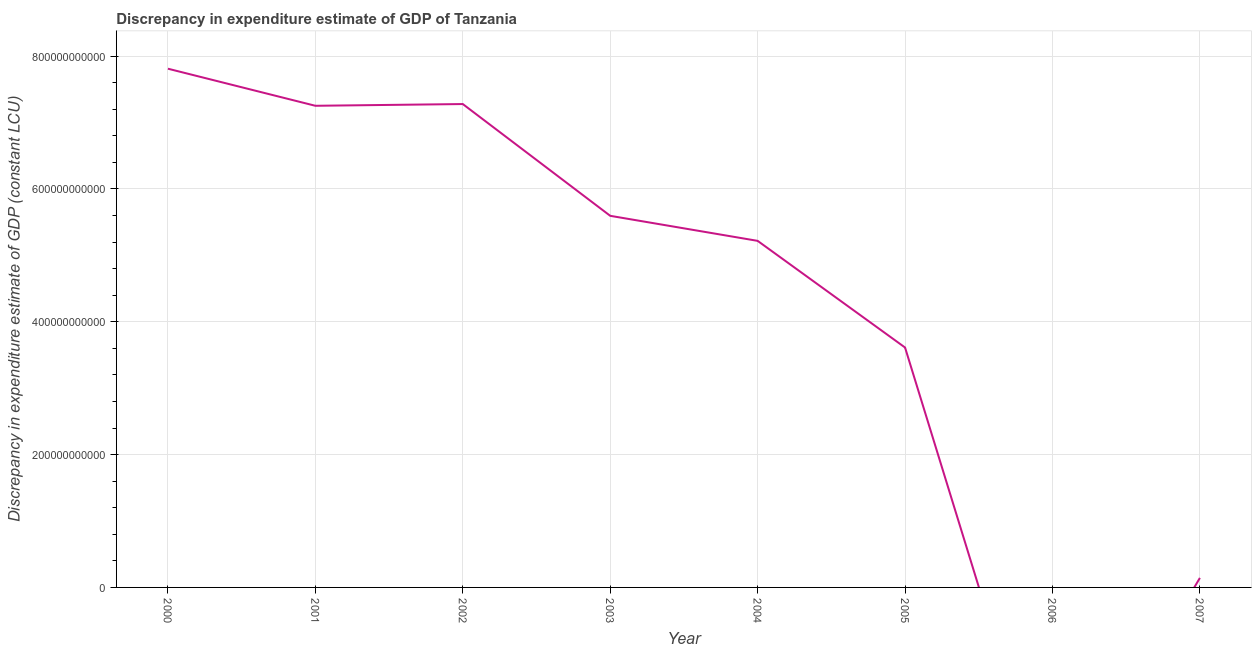What is the discrepancy in expenditure estimate of gdp in 2003?
Offer a terse response. 5.59e+11. Across all years, what is the maximum discrepancy in expenditure estimate of gdp?
Offer a very short reply. 7.81e+11. Across all years, what is the minimum discrepancy in expenditure estimate of gdp?
Give a very brief answer. 0. In which year was the discrepancy in expenditure estimate of gdp maximum?
Give a very brief answer. 2000. What is the sum of the discrepancy in expenditure estimate of gdp?
Keep it short and to the point. 3.69e+12. What is the difference between the discrepancy in expenditure estimate of gdp in 2002 and 2007?
Make the answer very short. 7.13e+11. What is the average discrepancy in expenditure estimate of gdp per year?
Make the answer very short. 4.61e+11. What is the median discrepancy in expenditure estimate of gdp?
Give a very brief answer. 5.41e+11. What is the ratio of the discrepancy in expenditure estimate of gdp in 2001 to that in 2004?
Offer a terse response. 1.39. Is the discrepancy in expenditure estimate of gdp in 2000 less than that in 2002?
Make the answer very short. No. What is the difference between the highest and the second highest discrepancy in expenditure estimate of gdp?
Offer a very short reply. 5.32e+1. What is the difference between the highest and the lowest discrepancy in expenditure estimate of gdp?
Provide a succinct answer. 7.81e+11. Does the discrepancy in expenditure estimate of gdp monotonically increase over the years?
Keep it short and to the point. No. How many lines are there?
Your answer should be very brief. 1. How many years are there in the graph?
Keep it short and to the point. 8. What is the difference between two consecutive major ticks on the Y-axis?
Keep it short and to the point. 2.00e+11. What is the title of the graph?
Keep it short and to the point. Discrepancy in expenditure estimate of GDP of Tanzania. What is the label or title of the X-axis?
Your response must be concise. Year. What is the label or title of the Y-axis?
Your response must be concise. Discrepancy in expenditure estimate of GDP (constant LCU). What is the Discrepancy in expenditure estimate of GDP (constant LCU) in 2000?
Offer a terse response. 7.81e+11. What is the Discrepancy in expenditure estimate of GDP (constant LCU) of 2001?
Ensure brevity in your answer.  7.25e+11. What is the Discrepancy in expenditure estimate of GDP (constant LCU) in 2002?
Ensure brevity in your answer.  7.28e+11. What is the Discrepancy in expenditure estimate of GDP (constant LCU) in 2003?
Keep it short and to the point. 5.59e+11. What is the Discrepancy in expenditure estimate of GDP (constant LCU) of 2004?
Give a very brief answer. 5.22e+11. What is the Discrepancy in expenditure estimate of GDP (constant LCU) in 2005?
Provide a succinct answer. 3.61e+11. What is the Discrepancy in expenditure estimate of GDP (constant LCU) in 2007?
Provide a short and direct response. 1.43e+1. What is the difference between the Discrepancy in expenditure estimate of GDP (constant LCU) in 2000 and 2001?
Provide a succinct answer. 5.58e+1. What is the difference between the Discrepancy in expenditure estimate of GDP (constant LCU) in 2000 and 2002?
Offer a very short reply. 5.32e+1. What is the difference between the Discrepancy in expenditure estimate of GDP (constant LCU) in 2000 and 2003?
Offer a very short reply. 2.21e+11. What is the difference between the Discrepancy in expenditure estimate of GDP (constant LCU) in 2000 and 2004?
Offer a terse response. 2.59e+11. What is the difference between the Discrepancy in expenditure estimate of GDP (constant LCU) in 2000 and 2005?
Keep it short and to the point. 4.20e+11. What is the difference between the Discrepancy in expenditure estimate of GDP (constant LCU) in 2000 and 2007?
Offer a very short reply. 7.67e+11. What is the difference between the Discrepancy in expenditure estimate of GDP (constant LCU) in 2001 and 2002?
Your response must be concise. -2.62e+09. What is the difference between the Discrepancy in expenditure estimate of GDP (constant LCU) in 2001 and 2003?
Make the answer very short. 1.66e+11. What is the difference between the Discrepancy in expenditure estimate of GDP (constant LCU) in 2001 and 2004?
Offer a terse response. 2.03e+11. What is the difference between the Discrepancy in expenditure estimate of GDP (constant LCU) in 2001 and 2005?
Make the answer very short. 3.64e+11. What is the difference between the Discrepancy in expenditure estimate of GDP (constant LCU) in 2001 and 2007?
Provide a succinct answer. 7.11e+11. What is the difference between the Discrepancy in expenditure estimate of GDP (constant LCU) in 2002 and 2003?
Ensure brevity in your answer.  1.68e+11. What is the difference between the Discrepancy in expenditure estimate of GDP (constant LCU) in 2002 and 2004?
Your answer should be very brief. 2.06e+11. What is the difference between the Discrepancy in expenditure estimate of GDP (constant LCU) in 2002 and 2005?
Keep it short and to the point. 3.67e+11. What is the difference between the Discrepancy in expenditure estimate of GDP (constant LCU) in 2002 and 2007?
Offer a very short reply. 7.13e+11. What is the difference between the Discrepancy in expenditure estimate of GDP (constant LCU) in 2003 and 2004?
Your answer should be very brief. 3.77e+1. What is the difference between the Discrepancy in expenditure estimate of GDP (constant LCU) in 2003 and 2005?
Provide a succinct answer. 1.98e+11. What is the difference between the Discrepancy in expenditure estimate of GDP (constant LCU) in 2003 and 2007?
Keep it short and to the point. 5.45e+11. What is the difference between the Discrepancy in expenditure estimate of GDP (constant LCU) in 2004 and 2005?
Provide a short and direct response. 1.61e+11. What is the difference between the Discrepancy in expenditure estimate of GDP (constant LCU) in 2004 and 2007?
Your response must be concise. 5.07e+11. What is the difference between the Discrepancy in expenditure estimate of GDP (constant LCU) in 2005 and 2007?
Make the answer very short. 3.47e+11. What is the ratio of the Discrepancy in expenditure estimate of GDP (constant LCU) in 2000 to that in 2001?
Your answer should be compact. 1.08. What is the ratio of the Discrepancy in expenditure estimate of GDP (constant LCU) in 2000 to that in 2002?
Your answer should be compact. 1.07. What is the ratio of the Discrepancy in expenditure estimate of GDP (constant LCU) in 2000 to that in 2003?
Offer a terse response. 1.4. What is the ratio of the Discrepancy in expenditure estimate of GDP (constant LCU) in 2000 to that in 2004?
Your answer should be very brief. 1.5. What is the ratio of the Discrepancy in expenditure estimate of GDP (constant LCU) in 2000 to that in 2005?
Keep it short and to the point. 2.16. What is the ratio of the Discrepancy in expenditure estimate of GDP (constant LCU) in 2000 to that in 2007?
Offer a very short reply. 54.54. What is the ratio of the Discrepancy in expenditure estimate of GDP (constant LCU) in 2001 to that in 2002?
Your response must be concise. 1. What is the ratio of the Discrepancy in expenditure estimate of GDP (constant LCU) in 2001 to that in 2003?
Ensure brevity in your answer.  1.3. What is the ratio of the Discrepancy in expenditure estimate of GDP (constant LCU) in 2001 to that in 2004?
Your answer should be very brief. 1.39. What is the ratio of the Discrepancy in expenditure estimate of GDP (constant LCU) in 2001 to that in 2005?
Give a very brief answer. 2.01. What is the ratio of the Discrepancy in expenditure estimate of GDP (constant LCU) in 2001 to that in 2007?
Offer a very short reply. 50.64. What is the ratio of the Discrepancy in expenditure estimate of GDP (constant LCU) in 2002 to that in 2003?
Keep it short and to the point. 1.3. What is the ratio of the Discrepancy in expenditure estimate of GDP (constant LCU) in 2002 to that in 2004?
Ensure brevity in your answer.  1.4. What is the ratio of the Discrepancy in expenditure estimate of GDP (constant LCU) in 2002 to that in 2005?
Give a very brief answer. 2.02. What is the ratio of the Discrepancy in expenditure estimate of GDP (constant LCU) in 2002 to that in 2007?
Your answer should be compact. 50.82. What is the ratio of the Discrepancy in expenditure estimate of GDP (constant LCU) in 2003 to that in 2004?
Keep it short and to the point. 1.07. What is the ratio of the Discrepancy in expenditure estimate of GDP (constant LCU) in 2003 to that in 2005?
Keep it short and to the point. 1.55. What is the ratio of the Discrepancy in expenditure estimate of GDP (constant LCU) in 2003 to that in 2007?
Provide a succinct answer. 39.07. What is the ratio of the Discrepancy in expenditure estimate of GDP (constant LCU) in 2004 to that in 2005?
Your response must be concise. 1.45. What is the ratio of the Discrepancy in expenditure estimate of GDP (constant LCU) in 2004 to that in 2007?
Your answer should be compact. 36.44. What is the ratio of the Discrepancy in expenditure estimate of GDP (constant LCU) in 2005 to that in 2007?
Offer a very short reply. 25.22. 